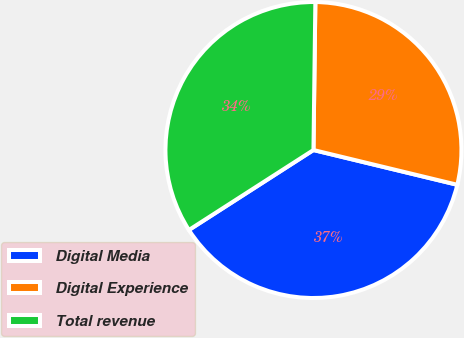Convert chart. <chart><loc_0><loc_0><loc_500><loc_500><pie_chart><fcel>Digital Media<fcel>Digital Experience<fcel>Total revenue<nl><fcel>37.14%<fcel>28.57%<fcel>34.29%<nl></chart> 